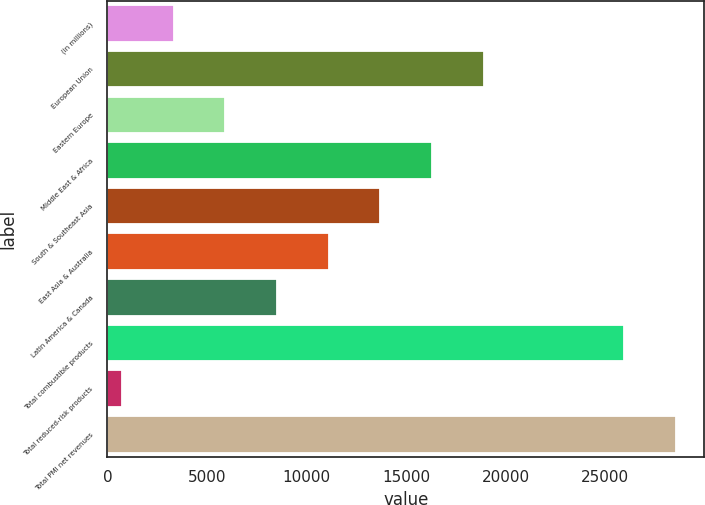Convert chart. <chart><loc_0><loc_0><loc_500><loc_500><bar_chart><fcel>(in millions)<fcel>European Union<fcel>Eastern Europe<fcel>Middle East & Africa<fcel>South & Southeast Asia<fcel>East Asia & Australia<fcel>Latin America & Canada<fcel>Total combustible products<fcel>Total reduced-risk products<fcel>Total PMI net revenues<nl><fcel>3328.2<fcel>18899.4<fcel>5923.4<fcel>16304.2<fcel>13709<fcel>11113.8<fcel>8518.6<fcel>25952<fcel>733<fcel>28547.2<nl></chart> 